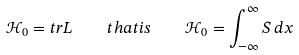<formula> <loc_0><loc_0><loc_500><loc_500>\mathcal { H } _ { 0 } = t r L \quad t h a t i s \quad \mathcal { H } _ { 0 } = \int _ { - \infty } ^ { \infty } S \, d x</formula> 